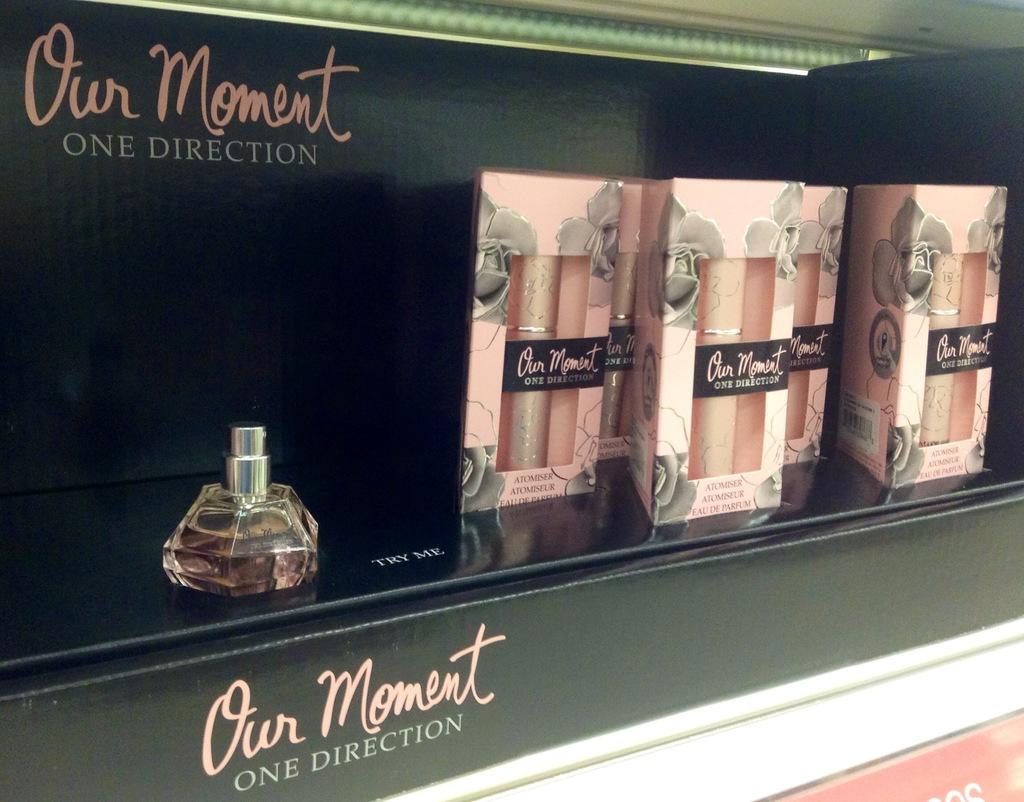<image>
Render a clear and concise summary of the photo. Our moment One direction perfume in a black case. 